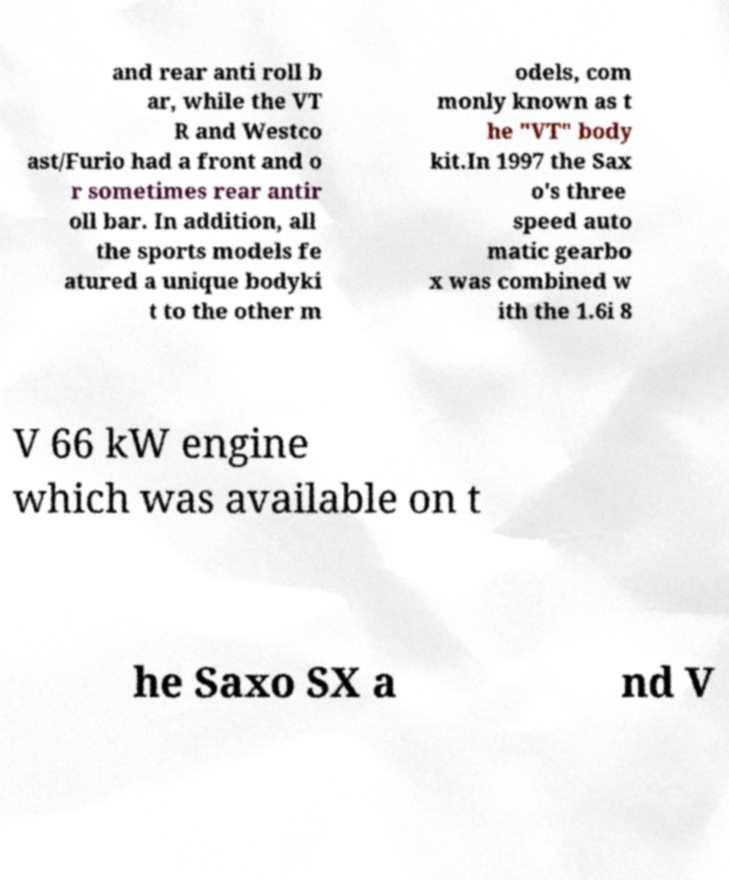Please identify and transcribe the text found in this image. and rear anti roll b ar, while the VT R and Westco ast/Furio had a front and o r sometimes rear antir oll bar. In addition, all the sports models fe atured a unique bodyki t to the other m odels, com monly known as t he "VT" body kit.In 1997 the Sax o's three speed auto matic gearbo x was combined w ith the 1.6i 8 V 66 kW engine which was available on t he Saxo SX a nd V 